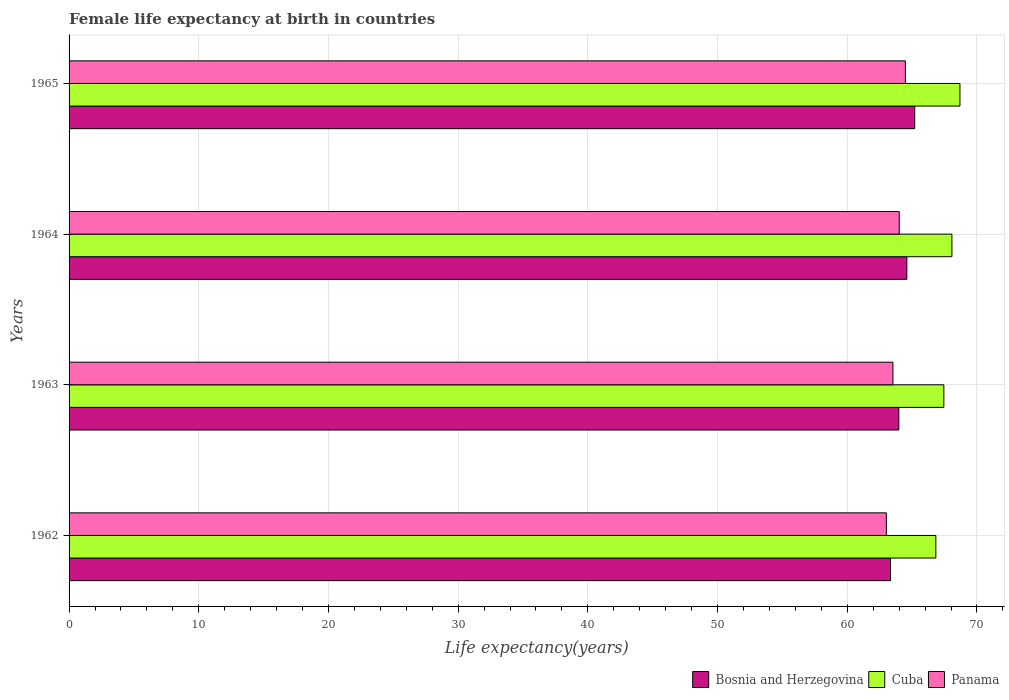How many bars are there on the 3rd tick from the top?
Your response must be concise. 3. How many bars are there on the 4th tick from the bottom?
Ensure brevity in your answer.  3. What is the label of the 4th group of bars from the top?
Your response must be concise. 1962. In how many cases, is the number of bars for a given year not equal to the number of legend labels?
Your response must be concise. 0. What is the female life expectancy at birth in Cuba in 1962?
Offer a very short reply. 66.83. Across all years, what is the maximum female life expectancy at birth in Bosnia and Herzegovina?
Provide a short and direct response. 65.2. Across all years, what is the minimum female life expectancy at birth in Bosnia and Herzegovina?
Your answer should be very brief. 63.33. In which year was the female life expectancy at birth in Panama maximum?
Offer a terse response. 1965. What is the total female life expectancy at birth in Cuba in the graph?
Your answer should be compact. 271.03. What is the difference between the female life expectancy at birth in Bosnia and Herzegovina in 1962 and that in 1963?
Your response must be concise. -0.64. What is the difference between the female life expectancy at birth in Cuba in 1964 and the female life expectancy at birth in Panama in 1965?
Your answer should be very brief. 3.59. What is the average female life expectancy at birth in Cuba per year?
Provide a short and direct response. 67.76. In the year 1964, what is the difference between the female life expectancy at birth in Cuba and female life expectancy at birth in Panama?
Make the answer very short. 4.06. In how many years, is the female life expectancy at birth in Panama greater than 64 years?
Give a very brief answer. 2. What is the ratio of the female life expectancy at birth in Cuba in 1963 to that in 1964?
Your answer should be very brief. 0.99. Is the female life expectancy at birth in Panama in 1963 less than that in 1965?
Your answer should be very brief. Yes. What is the difference between the highest and the second highest female life expectancy at birth in Cuba?
Offer a terse response. 0.62. What is the difference between the highest and the lowest female life expectancy at birth in Cuba?
Make the answer very short. 1.86. Is the sum of the female life expectancy at birth in Cuba in 1964 and 1965 greater than the maximum female life expectancy at birth in Bosnia and Herzegovina across all years?
Your answer should be compact. Yes. What does the 3rd bar from the top in 1963 represents?
Offer a very short reply. Bosnia and Herzegovina. What does the 3rd bar from the bottom in 1964 represents?
Make the answer very short. Panama. Is it the case that in every year, the sum of the female life expectancy at birth in Cuba and female life expectancy at birth in Bosnia and Herzegovina is greater than the female life expectancy at birth in Panama?
Your answer should be very brief. Yes. Are all the bars in the graph horizontal?
Your answer should be compact. Yes. Does the graph contain grids?
Provide a short and direct response. Yes. How many legend labels are there?
Provide a short and direct response. 3. What is the title of the graph?
Provide a succinct answer. Female life expectancy at birth in countries. Does "Uruguay" appear as one of the legend labels in the graph?
Provide a short and direct response. No. What is the label or title of the X-axis?
Ensure brevity in your answer.  Life expectancy(years). What is the label or title of the Y-axis?
Keep it short and to the point. Years. What is the Life expectancy(years) in Bosnia and Herzegovina in 1962?
Offer a terse response. 63.33. What is the Life expectancy(years) in Cuba in 1962?
Your answer should be compact. 66.83. What is the Life expectancy(years) in Panama in 1962?
Keep it short and to the point. 63.02. What is the Life expectancy(years) in Bosnia and Herzegovina in 1963?
Your response must be concise. 63.98. What is the Life expectancy(years) of Cuba in 1963?
Give a very brief answer. 67.45. What is the Life expectancy(years) in Panama in 1963?
Give a very brief answer. 63.52. What is the Life expectancy(years) of Bosnia and Herzegovina in 1964?
Keep it short and to the point. 64.59. What is the Life expectancy(years) in Cuba in 1964?
Provide a short and direct response. 68.07. What is the Life expectancy(years) in Panama in 1964?
Your answer should be compact. 64.01. What is the Life expectancy(years) of Bosnia and Herzegovina in 1965?
Give a very brief answer. 65.2. What is the Life expectancy(years) of Cuba in 1965?
Your answer should be compact. 68.69. What is the Life expectancy(years) in Panama in 1965?
Ensure brevity in your answer.  64.48. Across all years, what is the maximum Life expectancy(years) of Bosnia and Herzegovina?
Keep it short and to the point. 65.2. Across all years, what is the maximum Life expectancy(years) of Cuba?
Offer a very short reply. 68.69. Across all years, what is the maximum Life expectancy(years) of Panama?
Offer a terse response. 64.48. Across all years, what is the minimum Life expectancy(years) of Bosnia and Herzegovina?
Offer a terse response. 63.33. Across all years, what is the minimum Life expectancy(years) of Cuba?
Ensure brevity in your answer.  66.83. Across all years, what is the minimum Life expectancy(years) in Panama?
Offer a very short reply. 63.02. What is the total Life expectancy(years) in Bosnia and Herzegovina in the graph?
Provide a short and direct response. 257.11. What is the total Life expectancy(years) in Cuba in the graph?
Provide a short and direct response. 271.03. What is the total Life expectancy(years) in Panama in the graph?
Your answer should be very brief. 255.02. What is the difference between the Life expectancy(years) of Bosnia and Herzegovina in 1962 and that in 1963?
Provide a short and direct response. -0.64. What is the difference between the Life expectancy(years) in Cuba in 1962 and that in 1963?
Your answer should be compact. -0.62. What is the difference between the Life expectancy(years) in Panama in 1962 and that in 1963?
Provide a short and direct response. -0.51. What is the difference between the Life expectancy(years) of Bosnia and Herzegovina in 1962 and that in 1964?
Your response must be concise. -1.26. What is the difference between the Life expectancy(years) in Cuba in 1962 and that in 1964?
Your answer should be compact. -1.24. What is the difference between the Life expectancy(years) of Panama in 1962 and that in 1964?
Ensure brevity in your answer.  -0.99. What is the difference between the Life expectancy(years) in Bosnia and Herzegovina in 1962 and that in 1965?
Offer a very short reply. -1.87. What is the difference between the Life expectancy(years) of Cuba in 1962 and that in 1965?
Offer a terse response. -1.86. What is the difference between the Life expectancy(years) in Panama in 1962 and that in 1965?
Your response must be concise. -1.47. What is the difference between the Life expectancy(years) of Bosnia and Herzegovina in 1963 and that in 1964?
Your answer should be very brief. -0.62. What is the difference between the Life expectancy(years) in Cuba in 1963 and that in 1964?
Give a very brief answer. -0.62. What is the difference between the Life expectancy(years) of Panama in 1963 and that in 1964?
Give a very brief answer. -0.49. What is the difference between the Life expectancy(years) of Bosnia and Herzegovina in 1963 and that in 1965?
Your answer should be very brief. -1.23. What is the difference between the Life expectancy(years) in Cuba in 1963 and that in 1965?
Keep it short and to the point. -1.24. What is the difference between the Life expectancy(years) in Panama in 1963 and that in 1965?
Provide a short and direct response. -0.96. What is the difference between the Life expectancy(years) of Bosnia and Herzegovina in 1964 and that in 1965?
Provide a short and direct response. -0.61. What is the difference between the Life expectancy(years) of Cuba in 1964 and that in 1965?
Offer a very short reply. -0.62. What is the difference between the Life expectancy(years) in Panama in 1964 and that in 1965?
Offer a very short reply. -0.47. What is the difference between the Life expectancy(years) in Bosnia and Herzegovina in 1962 and the Life expectancy(years) in Cuba in 1963?
Your answer should be compact. -4.11. What is the difference between the Life expectancy(years) of Bosnia and Herzegovina in 1962 and the Life expectancy(years) of Panama in 1963?
Keep it short and to the point. -0.19. What is the difference between the Life expectancy(years) of Cuba in 1962 and the Life expectancy(years) of Panama in 1963?
Make the answer very short. 3.31. What is the difference between the Life expectancy(years) of Bosnia and Herzegovina in 1962 and the Life expectancy(years) of Cuba in 1964?
Provide a succinct answer. -4.74. What is the difference between the Life expectancy(years) of Bosnia and Herzegovina in 1962 and the Life expectancy(years) of Panama in 1964?
Offer a terse response. -0.67. What is the difference between the Life expectancy(years) of Cuba in 1962 and the Life expectancy(years) of Panama in 1964?
Ensure brevity in your answer.  2.82. What is the difference between the Life expectancy(years) in Bosnia and Herzegovina in 1962 and the Life expectancy(years) in Cuba in 1965?
Ensure brevity in your answer.  -5.36. What is the difference between the Life expectancy(years) of Bosnia and Herzegovina in 1962 and the Life expectancy(years) of Panama in 1965?
Provide a short and direct response. -1.15. What is the difference between the Life expectancy(years) in Cuba in 1962 and the Life expectancy(years) in Panama in 1965?
Keep it short and to the point. 2.35. What is the difference between the Life expectancy(years) of Bosnia and Herzegovina in 1963 and the Life expectancy(years) of Cuba in 1964?
Provide a succinct answer. -4.09. What is the difference between the Life expectancy(years) of Bosnia and Herzegovina in 1963 and the Life expectancy(years) of Panama in 1964?
Ensure brevity in your answer.  -0.03. What is the difference between the Life expectancy(years) in Cuba in 1963 and the Life expectancy(years) in Panama in 1964?
Offer a terse response. 3.44. What is the difference between the Life expectancy(years) in Bosnia and Herzegovina in 1963 and the Life expectancy(years) in Cuba in 1965?
Give a very brief answer. -4.71. What is the difference between the Life expectancy(years) of Bosnia and Herzegovina in 1963 and the Life expectancy(years) of Panama in 1965?
Your answer should be very brief. -0.51. What is the difference between the Life expectancy(years) of Cuba in 1963 and the Life expectancy(years) of Panama in 1965?
Make the answer very short. 2.96. What is the difference between the Life expectancy(years) in Bosnia and Herzegovina in 1964 and the Life expectancy(years) in Cuba in 1965?
Your answer should be compact. -4.09. What is the difference between the Life expectancy(years) in Bosnia and Herzegovina in 1964 and the Life expectancy(years) in Panama in 1965?
Offer a terse response. 0.11. What is the difference between the Life expectancy(years) in Cuba in 1964 and the Life expectancy(years) in Panama in 1965?
Offer a terse response. 3.59. What is the average Life expectancy(years) of Bosnia and Herzegovina per year?
Make the answer very short. 64.28. What is the average Life expectancy(years) in Cuba per year?
Provide a short and direct response. 67.76. What is the average Life expectancy(years) in Panama per year?
Your response must be concise. 63.76. In the year 1962, what is the difference between the Life expectancy(years) of Bosnia and Herzegovina and Life expectancy(years) of Cuba?
Keep it short and to the point. -3.5. In the year 1962, what is the difference between the Life expectancy(years) in Bosnia and Herzegovina and Life expectancy(years) in Panama?
Your response must be concise. 0.32. In the year 1962, what is the difference between the Life expectancy(years) in Cuba and Life expectancy(years) in Panama?
Your answer should be very brief. 3.81. In the year 1963, what is the difference between the Life expectancy(years) in Bosnia and Herzegovina and Life expectancy(years) in Cuba?
Your response must be concise. -3.47. In the year 1963, what is the difference between the Life expectancy(years) in Bosnia and Herzegovina and Life expectancy(years) in Panama?
Ensure brevity in your answer.  0.46. In the year 1963, what is the difference between the Life expectancy(years) of Cuba and Life expectancy(years) of Panama?
Keep it short and to the point. 3.93. In the year 1964, what is the difference between the Life expectancy(years) in Bosnia and Herzegovina and Life expectancy(years) in Cuba?
Your response must be concise. -3.47. In the year 1964, what is the difference between the Life expectancy(years) in Bosnia and Herzegovina and Life expectancy(years) in Panama?
Ensure brevity in your answer.  0.59. In the year 1964, what is the difference between the Life expectancy(years) in Cuba and Life expectancy(years) in Panama?
Offer a terse response. 4.06. In the year 1965, what is the difference between the Life expectancy(years) of Bosnia and Herzegovina and Life expectancy(years) of Cuba?
Your answer should be compact. -3.48. In the year 1965, what is the difference between the Life expectancy(years) of Bosnia and Herzegovina and Life expectancy(years) of Panama?
Keep it short and to the point. 0.72. In the year 1965, what is the difference between the Life expectancy(years) of Cuba and Life expectancy(years) of Panama?
Offer a terse response. 4.21. What is the ratio of the Life expectancy(years) of Cuba in 1962 to that in 1963?
Offer a terse response. 0.99. What is the ratio of the Life expectancy(years) in Bosnia and Herzegovina in 1962 to that in 1964?
Your response must be concise. 0.98. What is the ratio of the Life expectancy(years) of Cuba in 1962 to that in 1964?
Give a very brief answer. 0.98. What is the ratio of the Life expectancy(years) of Panama in 1962 to that in 1964?
Give a very brief answer. 0.98. What is the ratio of the Life expectancy(years) of Bosnia and Herzegovina in 1962 to that in 1965?
Keep it short and to the point. 0.97. What is the ratio of the Life expectancy(years) of Panama in 1962 to that in 1965?
Offer a very short reply. 0.98. What is the ratio of the Life expectancy(years) of Bosnia and Herzegovina in 1963 to that in 1964?
Provide a short and direct response. 0.99. What is the ratio of the Life expectancy(years) of Cuba in 1963 to that in 1964?
Offer a very short reply. 0.99. What is the ratio of the Life expectancy(years) in Bosnia and Herzegovina in 1963 to that in 1965?
Make the answer very short. 0.98. What is the ratio of the Life expectancy(years) of Cuba in 1963 to that in 1965?
Keep it short and to the point. 0.98. What is the ratio of the Life expectancy(years) in Panama in 1963 to that in 1965?
Give a very brief answer. 0.99. What is the ratio of the Life expectancy(years) of Bosnia and Herzegovina in 1964 to that in 1965?
Give a very brief answer. 0.99. What is the ratio of the Life expectancy(years) of Panama in 1964 to that in 1965?
Offer a very short reply. 0.99. What is the difference between the highest and the second highest Life expectancy(years) in Bosnia and Herzegovina?
Your response must be concise. 0.61. What is the difference between the highest and the second highest Life expectancy(years) in Cuba?
Your response must be concise. 0.62. What is the difference between the highest and the second highest Life expectancy(years) in Panama?
Your response must be concise. 0.47. What is the difference between the highest and the lowest Life expectancy(years) of Bosnia and Herzegovina?
Provide a succinct answer. 1.87. What is the difference between the highest and the lowest Life expectancy(years) of Cuba?
Make the answer very short. 1.86. What is the difference between the highest and the lowest Life expectancy(years) in Panama?
Provide a succinct answer. 1.47. 